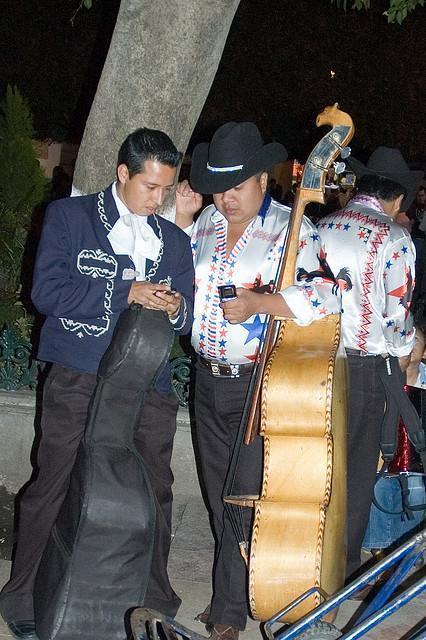How many cowboy hats?
Give a very brief answer. 2. How many people are there?
Give a very brief answer. 3. 